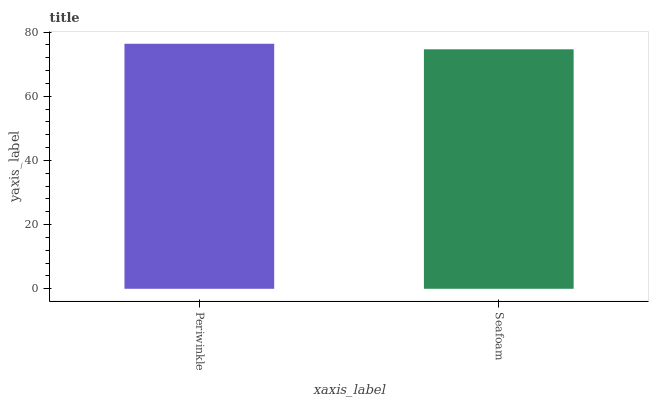Is Seafoam the minimum?
Answer yes or no. Yes. Is Periwinkle the maximum?
Answer yes or no. Yes. Is Seafoam the maximum?
Answer yes or no. No. Is Periwinkle greater than Seafoam?
Answer yes or no. Yes. Is Seafoam less than Periwinkle?
Answer yes or no. Yes. Is Seafoam greater than Periwinkle?
Answer yes or no. No. Is Periwinkle less than Seafoam?
Answer yes or no. No. Is Periwinkle the high median?
Answer yes or no. Yes. Is Seafoam the low median?
Answer yes or no. Yes. Is Seafoam the high median?
Answer yes or no. No. Is Periwinkle the low median?
Answer yes or no. No. 